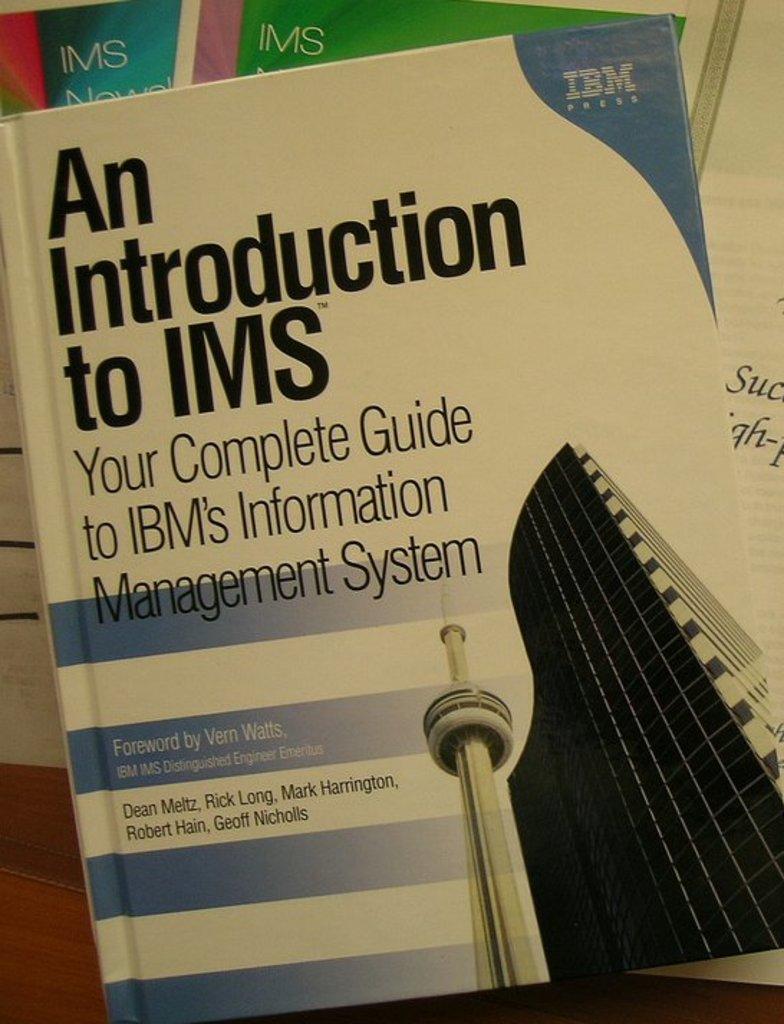What is this a complete guide to?
Offer a very short reply. Ibm's information management system. What company created this guide?
Provide a short and direct response. Ibm. 